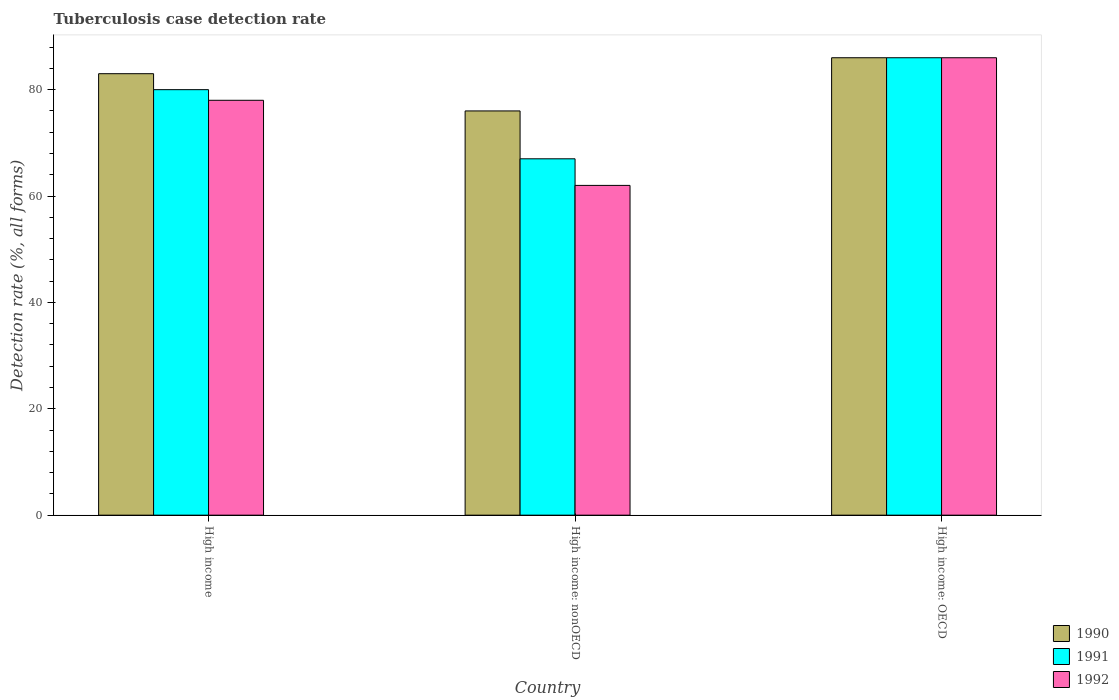How many groups of bars are there?
Provide a succinct answer. 3. Are the number of bars per tick equal to the number of legend labels?
Keep it short and to the point. Yes. Are the number of bars on each tick of the X-axis equal?
Provide a short and direct response. Yes. How many bars are there on the 3rd tick from the right?
Your answer should be compact. 3. Across all countries, what is the minimum tuberculosis case detection rate in in 1991?
Keep it short and to the point. 67. In which country was the tuberculosis case detection rate in in 1992 maximum?
Provide a succinct answer. High income: OECD. In which country was the tuberculosis case detection rate in in 1991 minimum?
Your answer should be compact. High income: nonOECD. What is the total tuberculosis case detection rate in in 1992 in the graph?
Ensure brevity in your answer.  226. What is the difference between the tuberculosis case detection rate in in 1990 in High income: nonOECD and the tuberculosis case detection rate in in 1992 in High income?
Offer a very short reply. -2. What is the average tuberculosis case detection rate in in 1990 per country?
Your answer should be compact. 81.67. What is the ratio of the tuberculosis case detection rate in in 1990 in High income to that in High income: nonOECD?
Give a very brief answer. 1.09. What is the difference between the highest and the second highest tuberculosis case detection rate in in 1992?
Your answer should be compact. -16. In how many countries, is the tuberculosis case detection rate in in 1991 greater than the average tuberculosis case detection rate in in 1991 taken over all countries?
Your response must be concise. 2. What does the 2nd bar from the right in High income: OECD represents?
Make the answer very short. 1991. Is it the case that in every country, the sum of the tuberculosis case detection rate in in 1990 and tuberculosis case detection rate in in 1991 is greater than the tuberculosis case detection rate in in 1992?
Provide a short and direct response. Yes. How many bars are there?
Offer a terse response. 9. What is the difference between two consecutive major ticks on the Y-axis?
Offer a very short reply. 20. Are the values on the major ticks of Y-axis written in scientific E-notation?
Ensure brevity in your answer.  No. What is the title of the graph?
Your response must be concise. Tuberculosis case detection rate. Does "1965" appear as one of the legend labels in the graph?
Give a very brief answer. No. What is the label or title of the Y-axis?
Give a very brief answer. Detection rate (%, all forms). What is the Detection rate (%, all forms) of 1990 in High income?
Your answer should be compact. 83. What is the Detection rate (%, all forms) in 1991 in High income?
Keep it short and to the point. 80. What is the Detection rate (%, all forms) of 1992 in High income?
Give a very brief answer. 78. What is the Detection rate (%, all forms) in 1992 in High income: nonOECD?
Give a very brief answer. 62. What is the Detection rate (%, all forms) in 1992 in High income: OECD?
Your response must be concise. 86. Across all countries, what is the maximum Detection rate (%, all forms) in 1992?
Keep it short and to the point. 86. Across all countries, what is the minimum Detection rate (%, all forms) in 1991?
Your response must be concise. 67. Across all countries, what is the minimum Detection rate (%, all forms) of 1992?
Provide a succinct answer. 62. What is the total Detection rate (%, all forms) in 1990 in the graph?
Provide a short and direct response. 245. What is the total Detection rate (%, all forms) of 1991 in the graph?
Offer a terse response. 233. What is the total Detection rate (%, all forms) in 1992 in the graph?
Your answer should be very brief. 226. What is the difference between the Detection rate (%, all forms) of 1990 in High income and that in High income: nonOECD?
Provide a succinct answer. 7. What is the difference between the Detection rate (%, all forms) of 1991 in High income and that in High income: nonOECD?
Your answer should be very brief. 13. What is the difference between the Detection rate (%, all forms) of 1991 in High income and that in High income: OECD?
Make the answer very short. -6. What is the difference between the Detection rate (%, all forms) in 1992 in High income and that in High income: OECD?
Give a very brief answer. -8. What is the difference between the Detection rate (%, all forms) of 1991 in High income: nonOECD and that in High income: OECD?
Give a very brief answer. -19. What is the difference between the Detection rate (%, all forms) in 1990 in High income and the Detection rate (%, all forms) in 1992 in High income: nonOECD?
Provide a succinct answer. 21. What is the difference between the Detection rate (%, all forms) in 1990 in High income and the Detection rate (%, all forms) in 1992 in High income: OECD?
Your answer should be very brief. -3. What is the difference between the Detection rate (%, all forms) of 1990 in High income: nonOECD and the Detection rate (%, all forms) of 1991 in High income: OECD?
Your answer should be very brief. -10. What is the difference between the Detection rate (%, all forms) of 1990 in High income: nonOECD and the Detection rate (%, all forms) of 1992 in High income: OECD?
Your answer should be very brief. -10. What is the average Detection rate (%, all forms) of 1990 per country?
Your answer should be compact. 81.67. What is the average Detection rate (%, all forms) in 1991 per country?
Provide a succinct answer. 77.67. What is the average Detection rate (%, all forms) in 1992 per country?
Provide a short and direct response. 75.33. What is the difference between the Detection rate (%, all forms) of 1990 and Detection rate (%, all forms) of 1991 in High income?
Your response must be concise. 3. What is the difference between the Detection rate (%, all forms) in 1991 and Detection rate (%, all forms) in 1992 in High income?
Your answer should be very brief. 2. What is the difference between the Detection rate (%, all forms) of 1990 and Detection rate (%, all forms) of 1992 in High income: nonOECD?
Offer a terse response. 14. What is the difference between the Detection rate (%, all forms) of 1990 and Detection rate (%, all forms) of 1992 in High income: OECD?
Make the answer very short. 0. What is the difference between the Detection rate (%, all forms) of 1991 and Detection rate (%, all forms) of 1992 in High income: OECD?
Give a very brief answer. 0. What is the ratio of the Detection rate (%, all forms) in 1990 in High income to that in High income: nonOECD?
Provide a short and direct response. 1.09. What is the ratio of the Detection rate (%, all forms) of 1991 in High income to that in High income: nonOECD?
Provide a succinct answer. 1.19. What is the ratio of the Detection rate (%, all forms) of 1992 in High income to that in High income: nonOECD?
Keep it short and to the point. 1.26. What is the ratio of the Detection rate (%, all forms) of 1990 in High income to that in High income: OECD?
Keep it short and to the point. 0.97. What is the ratio of the Detection rate (%, all forms) of 1991 in High income to that in High income: OECD?
Give a very brief answer. 0.93. What is the ratio of the Detection rate (%, all forms) of 1992 in High income to that in High income: OECD?
Ensure brevity in your answer.  0.91. What is the ratio of the Detection rate (%, all forms) of 1990 in High income: nonOECD to that in High income: OECD?
Your answer should be very brief. 0.88. What is the ratio of the Detection rate (%, all forms) of 1991 in High income: nonOECD to that in High income: OECD?
Make the answer very short. 0.78. What is the ratio of the Detection rate (%, all forms) in 1992 in High income: nonOECD to that in High income: OECD?
Give a very brief answer. 0.72. What is the difference between the highest and the second highest Detection rate (%, all forms) of 1990?
Your answer should be compact. 3. What is the difference between the highest and the second highest Detection rate (%, all forms) in 1992?
Make the answer very short. 8. What is the difference between the highest and the lowest Detection rate (%, all forms) of 1990?
Offer a very short reply. 10. What is the difference between the highest and the lowest Detection rate (%, all forms) in 1991?
Your answer should be very brief. 19. What is the difference between the highest and the lowest Detection rate (%, all forms) of 1992?
Provide a succinct answer. 24. 